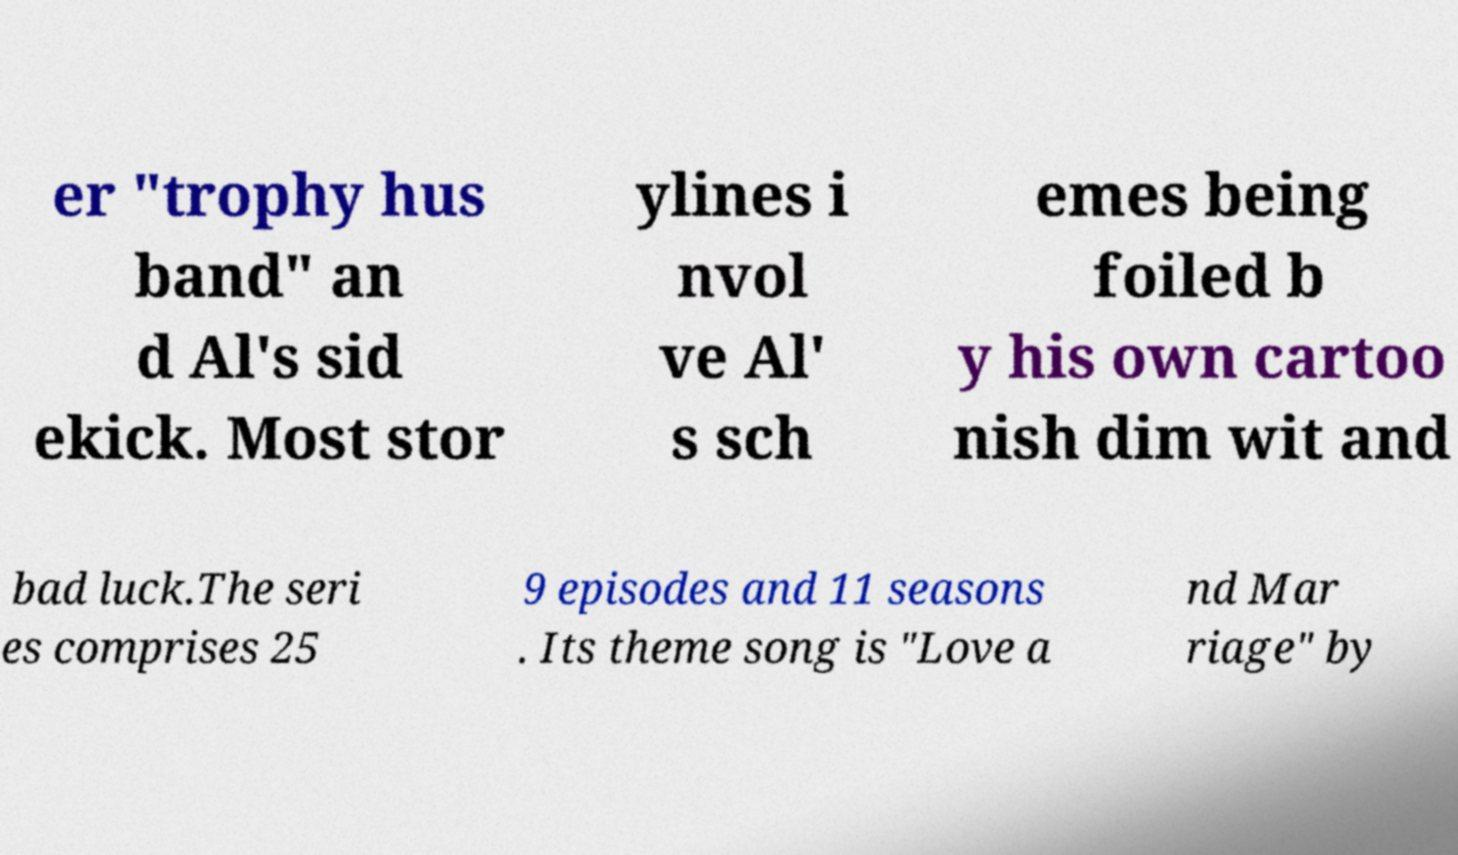Please identify and transcribe the text found in this image. er "trophy hus band" an d Al's sid ekick. Most stor ylines i nvol ve Al' s sch emes being foiled b y his own cartoo nish dim wit and bad luck.The seri es comprises 25 9 episodes and 11 seasons . Its theme song is "Love a nd Mar riage" by 